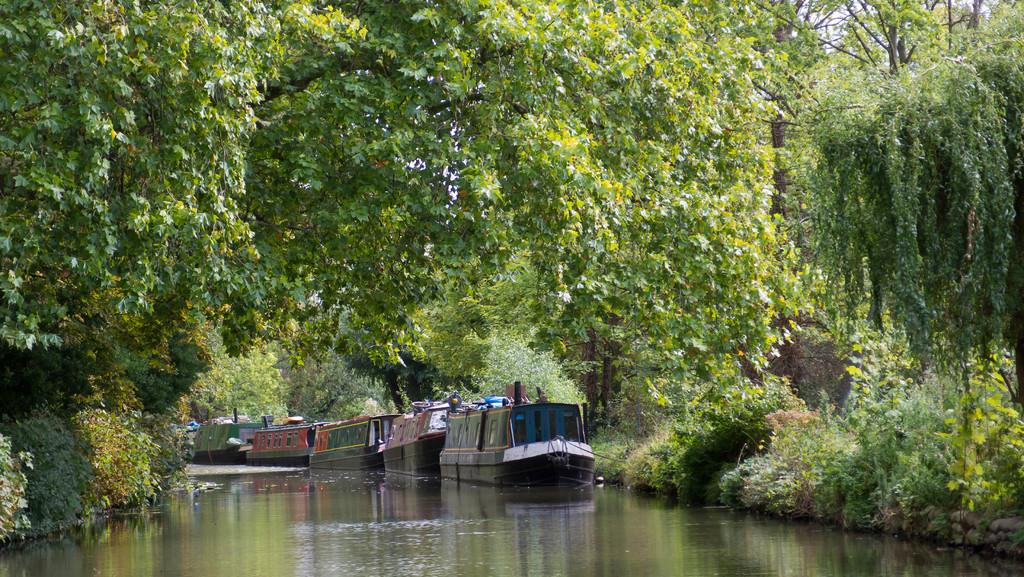What type of vegetation can be seen in the image? There are trees in the image. What is located at the bottom of the image? There is water at the bottom of the image. What is floating on the water in the image? There are boats on the water. What can be seen in the background of the image? The sky is visible in the background of the image. Where is the tramp located in the image? There is no tramp present in the image. What type of marble is visible in the image? There is no marble present in the image. 